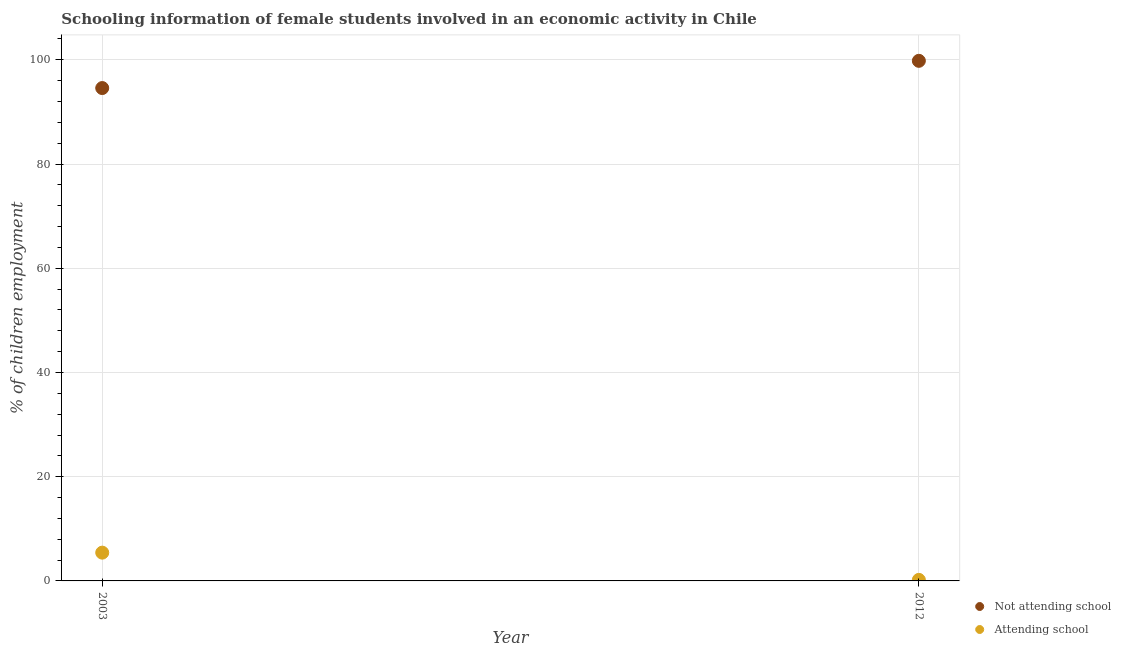What is the percentage of employed females who are not attending school in 2012?
Give a very brief answer. 99.8. Across all years, what is the maximum percentage of employed females who are not attending school?
Your answer should be compact. 99.8. Across all years, what is the minimum percentage of employed females who are not attending school?
Ensure brevity in your answer.  94.57. In which year was the percentage of employed females who are not attending school maximum?
Ensure brevity in your answer.  2012. In which year was the percentage of employed females who are attending school minimum?
Offer a very short reply. 2012. What is the total percentage of employed females who are attending school in the graph?
Provide a succinct answer. 5.63. What is the difference between the percentage of employed females who are not attending school in 2003 and that in 2012?
Keep it short and to the point. -5.23. What is the difference between the percentage of employed females who are attending school in 2003 and the percentage of employed females who are not attending school in 2012?
Ensure brevity in your answer.  -94.37. What is the average percentage of employed females who are not attending school per year?
Provide a succinct answer. 97.19. In the year 2003, what is the difference between the percentage of employed females who are attending school and percentage of employed females who are not attending school?
Your answer should be very brief. -89.15. What is the ratio of the percentage of employed females who are not attending school in 2003 to that in 2012?
Ensure brevity in your answer.  0.95. Is the percentage of employed females who are attending school in 2003 less than that in 2012?
Provide a succinct answer. No. In how many years, is the percentage of employed females who are attending school greater than the average percentage of employed females who are attending school taken over all years?
Your answer should be very brief. 1. Does the percentage of employed females who are not attending school monotonically increase over the years?
Provide a short and direct response. Yes. Is the percentage of employed females who are not attending school strictly less than the percentage of employed females who are attending school over the years?
Make the answer very short. No. How many years are there in the graph?
Your answer should be very brief. 2. What is the difference between two consecutive major ticks on the Y-axis?
Provide a succinct answer. 20. Are the values on the major ticks of Y-axis written in scientific E-notation?
Keep it short and to the point. No. Does the graph contain any zero values?
Give a very brief answer. No. Does the graph contain grids?
Your response must be concise. Yes. Where does the legend appear in the graph?
Offer a very short reply. Bottom right. How are the legend labels stacked?
Provide a short and direct response. Vertical. What is the title of the graph?
Provide a succinct answer. Schooling information of female students involved in an economic activity in Chile. Does "Under-5(male)" appear as one of the legend labels in the graph?
Keep it short and to the point. No. What is the label or title of the Y-axis?
Provide a succinct answer. % of children employment. What is the % of children employment of Not attending school in 2003?
Offer a very short reply. 94.57. What is the % of children employment of Attending school in 2003?
Offer a very short reply. 5.43. What is the % of children employment of Not attending school in 2012?
Offer a terse response. 99.8. Across all years, what is the maximum % of children employment of Not attending school?
Give a very brief answer. 99.8. Across all years, what is the maximum % of children employment in Attending school?
Your answer should be very brief. 5.43. Across all years, what is the minimum % of children employment in Not attending school?
Your answer should be very brief. 94.57. What is the total % of children employment of Not attending school in the graph?
Your answer should be compact. 194.37. What is the total % of children employment of Attending school in the graph?
Offer a terse response. 5.63. What is the difference between the % of children employment in Not attending school in 2003 and that in 2012?
Your response must be concise. -5.23. What is the difference between the % of children employment in Attending school in 2003 and that in 2012?
Offer a terse response. 5.23. What is the difference between the % of children employment of Not attending school in 2003 and the % of children employment of Attending school in 2012?
Your answer should be very brief. 94.37. What is the average % of children employment of Not attending school per year?
Make the answer very short. 97.19. What is the average % of children employment of Attending school per year?
Provide a short and direct response. 2.81. In the year 2003, what is the difference between the % of children employment in Not attending school and % of children employment in Attending school?
Offer a terse response. 89.15. In the year 2012, what is the difference between the % of children employment of Not attending school and % of children employment of Attending school?
Ensure brevity in your answer.  99.6. What is the ratio of the % of children employment of Not attending school in 2003 to that in 2012?
Provide a succinct answer. 0.95. What is the ratio of the % of children employment in Attending school in 2003 to that in 2012?
Provide a succinct answer. 27.13. What is the difference between the highest and the second highest % of children employment in Not attending school?
Keep it short and to the point. 5.23. What is the difference between the highest and the second highest % of children employment of Attending school?
Your answer should be very brief. 5.23. What is the difference between the highest and the lowest % of children employment in Not attending school?
Your answer should be compact. 5.23. What is the difference between the highest and the lowest % of children employment in Attending school?
Provide a short and direct response. 5.23. 